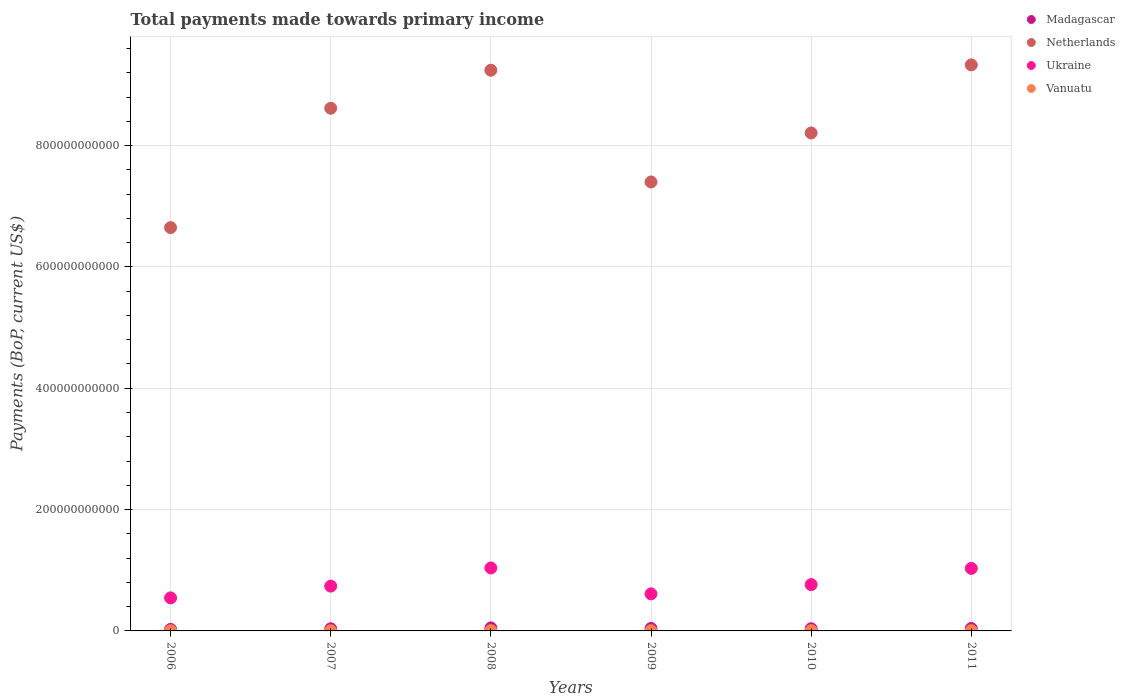Is the number of dotlines equal to the number of legend labels?
Your response must be concise. Yes. What is the total payments made towards primary income in Ukraine in 2009?
Your answer should be compact. 6.11e+1. Across all years, what is the maximum total payments made towards primary income in Ukraine?
Offer a very short reply. 1.04e+11. Across all years, what is the minimum total payments made towards primary income in Ukraine?
Provide a succinct answer. 5.45e+1. In which year was the total payments made towards primary income in Vanuatu maximum?
Keep it short and to the point. 2008. In which year was the total payments made towards primary income in Madagascar minimum?
Ensure brevity in your answer.  2006. What is the total total payments made towards primary income in Netherlands in the graph?
Offer a very short reply. 4.94e+12. What is the difference between the total payments made towards primary income in Netherlands in 2006 and that in 2009?
Ensure brevity in your answer.  -7.52e+1. What is the difference between the total payments made towards primary income in Netherlands in 2011 and the total payments made towards primary income in Ukraine in 2008?
Provide a succinct answer. 8.29e+11. What is the average total payments made towards primary income in Netherlands per year?
Your answer should be compact. 8.24e+11. In the year 2006, what is the difference between the total payments made towards primary income in Ukraine and total payments made towards primary income in Madagascar?
Keep it short and to the point. 5.20e+1. What is the ratio of the total payments made towards primary income in Ukraine in 2009 to that in 2010?
Ensure brevity in your answer.  0.8. Is the total payments made towards primary income in Vanuatu in 2006 less than that in 2007?
Ensure brevity in your answer.  Yes. What is the difference between the highest and the second highest total payments made towards primary income in Madagascar?
Offer a terse response. 8.70e+08. What is the difference between the highest and the lowest total payments made towards primary income in Madagascar?
Give a very brief answer. 2.44e+09. Is the sum of the total payments made towards primary income in Vanuatu in 2006 and 2009 greater than the maximum total payments made towards primary income in Ukraine across all years?
Provide a short and direct response. No. Is it the case that in every year, the sum of the total payments made towards primary income in Netherlands and total payments made towards primary income in Madagascar  is greater than the total payments made towards primary income in Vanuatu?
Your answer should be very brief. Yes. Does the total payments made towards primary income in Netherlands monotonically increase over the years?
Ensure brevity in your answer.  No. What is the difference between two consecutive major ticks on the Y-axis?
Offer a terse response. 2.00e+11. Are the values on the major ticks of Y-axis written in scientific E-notation?
Offer a very short reply. No. Does the graph contain grids?
Ensure brevity in your answer.  Yes. How many legend labels are there?
Provide a short and direct response. 4. What is the title of the graph?
Keep it short and to the point. Total payments made towards primary income. What is the label or title of the X-axis?
Ensure brevity in your answer.  Years. What is the label or title of the Y-axis?
Offer a very short reply. Payments (BoP, current US$). What is the Payments (BoP, current US$) in Madagascar in 2006?
Offer a terse response. 2.50e+09. What is the Payments (BoP, current US$) in Netherlands in 2006?
Keep it short and to the point. 6.65e+11. What is the Payments (BoP, current US$) in Ukraine in 2006?
Your response must be concise. 5.45e+1. What is the Payments (BoP, current US$) in Vanuatu in 2006?
Provide a short and direct response. 2.71e+08. What is the Payments (BoP, current US$) in Madagascar in 2007?
Provide a short and direct response. 3.55e+09. What is the Payments (BoP, current US$) in Netherlands in 2007?
Your response must be concise. 8.62e+11. What is the Payments (BoP, current US$) of Ukraine in 2007?
Offer a terse response. 7.39e+1. What is the Payments (BoP, current US$) in Vanuatu in 2007?
Offer a very short reply. 3.13e+08. What is the Payments (BoP, current US$) in Madagascar in 2008?
Make the answer very short. 4.94e+09. What is the Payments (BoP, current US$) in Netherlands in 2008?
Offer a very short reply. 9.24e+11. What is the Payments (BoP, current US$) of Ukraine in 2008?
Ensure brevity in your answer.  1.04e+11. What is the Payments (BoP, current US$) of Vanuatu in 2008?
Keep it short and to the point. 4.93e+08. What is the Payments (BoP, current US$) in Madagascar in 2009?
Provide a short and direct response. 4.07e+09. What is the Payments (BoP, current US$) of Netherlands in 2009?
Provide a short and direct response. 7.40e+11. What is the Payments (BoP, current US$) of Ukraine in 2009?
Your response must be concise. 6.11e+1. What is the Payments (BoP, current US$) of Vanuatu in 2009?
Offer a very short reply. 3.45e+08. What is the Payments (BoP, current US$) in Madagascar in 2010?
Make the answer very short. 3.62e+09. What is the Payments (BoP, current US$) of Netherlands in 2010?
Offer a very short reply. 8.21e+11. What is the Payments (BoP, current US$) of Ukraine in 2010?
Your answer should be very brief. 7.63e+1. What is the Payments (BoP, current US$) in Vanuatu in 2010?
Offer a terse response. 4.23e+08. What is the Payments (BoP, current US$) in Madagascar in 2011?
Keep it short and to the point. 4.02e+09. What is the Payments (BoP, current US$) of Netherlands in 2011?
Your answer should be compact. 9.33e+11. What is the Payments (BoP, current US$) in Ukraine in 2011?
Offer a terse response. 1.03e+11. What is the Payments (BoP, current US$) of Vanuatu in 2011?
Offer a very short reply. 4.66e+08. Across all years, what is the maximum Payments (BoP, current US$) in Madagascar?
Make the answer very short. 4.94e+09. Across all years, what is the maximum Payments (BoP, current US$) of Netherlands?
Your response must be concise. 9.33e+11. Across all years, what is the maximum Payments (BoP, current US$) in Ukraine?
Make the answer very short. 1.04e+11. Across all years, what is the maximum Payments (BoP, current US$) of Vanuatu?
Your answer should be very brief. 4.93e+08. Across all years, what is the minimum Payments (BoP, current US$) of Madagascar?
Your answer should be compact. 2.50e+09. Across all years, what is the minimum Payments (BoP, current US$) in Netherlands?
Offer a very short reply. 6.65e+11. Across all years, what is the minimum Payments (BoP, current US$) in Ukraine?
Offer a very short reply. 5.45e+1. Across all years, what is the minimum Payments (BoP, current US$) in Vanuatu?
Give a very brief answer. 2.71e+08. What is the total Payments (BoP, current US$) of Madagascar in the graph?
Your response must be concise. 2.27e+1. What is the total Payments (BoP, current US$) of Netherlands in the graph?
Offer a terse response. 4.94e+12. What is the total Payments (BoP, current US$) of Ukraine in the graph?
Make the answer very short. 4.73e+11. What is the total Payments (BoP, current US$) of Vanuatu in the graph?
Give a very brief answer. 2.31e+09. What is the difference between the Payments (BoP, current US$) of Madagascar in 2006 and that in 2007?
Your answer should be very brief. -1.05e+09. What is the difference between the Payments (BoP, current US$) of Netherlands in 2006 and that in 2007?
Offer a very short reply. -1.97e+11. What is the difference between the Payments (BoP, current US$) of Ukraine in 2006 and that in 2007?
Offer a terse response. -1.94e+1. What is the difference between the Payments (BoP, current US$) in Vanuatu in 2006 and that in 2007?
Keep it short and to the point. -4.24e+07. What is the difference between the Payments (BoP, current US$) of Madagascar in 2006 and that in 2008?
Offer a very short reply. -2.44e+09. What is the difference between the Payments (BoP, current US$) in Netherlands in 2006 and that in 2008?
Make the answer very short. -2.59e+11. What is the difference between the Payments (BoP, current US$) of Ukraine in 2006 and that in 2008?
Your answer should be very brief. -4.93e+1. What is the difference between the Payments (BoP, current US$) in Vanuatu in 2006 and that in 2008?
Provide a succinct answer. -2.22e+08. What is the difference between the Payments (BoP, current US$) of Madagascar in 2006 and that in 2009?
Your answer should be very brief. -1.57e+09. What is the difference between the Payments (BoP, current US$) in Netherlands in 2006 and that in 2009?
Give a very brief answer. -7.52e+1. What is the difference between the Payments (BoP, current US$) of Ukraine in 2006 and that in 2009?
Offer a very short reply. -6.62e+09. What is the difference between the Payments (BoP, current US$) of Vanuatu in 2006 and that in 2009?
Your answer should be very brief. -7.48e+07. What is the difference between the Payments (BoP, current US$) of Madagascar in 2006 and that in 2010?
Provide a succinct answer. -1.12e+09. What is the difference between the Payments (BoP, current US$) of Netherlands in 2006 and that in 2010?
Your response must be concise. -1.56e+11. What is the difference between the Payments (BoP, current US$) in Ukraine in 2006 and that in 2010?
Provide a short and direct response. -2.19e+1. What is the difference between the Payments (BoP, current US$) of Vanuatu in 2006 and that in 2010?
Your answer should be compact. -1.52e+08. What is the difference between the Payments (BoP, current US$) of Madagascar in 2006 and that in 2011?
Offer a terse response. -1.52e+09. What is the difference between the Payments (BoP, current US$) in Netherlands in 2006 and that in 2011?
Provide a short and direct response. -2.68e+11. What is the difference between the Payments (BoP, current US$) in Ukraine in 2006 and that in 2011?
Your answer should be very brief. -4.86e+1. What is the difference between the Payments (BoP, current US$) of Vanuatu in 2006 and that in 2011?
Provide a succinct answer. -1.95e+08. What is the difference between the Payments (BoP, current US$) in Madagascar in 2007 and that in 2008?
Keep it short and to the point. -1.39e+09. What is the difference between the Payments (BoP, current US$) of Netherlands in 2007 and that in 2008?
Ensure brevity in your answer.  -6.26e+1. What is the difference between the Payments (BoP, current US$) of Ukraine in 2007 and that in 2008?
Your answer should be very brief. -2.99e+1. What is the difference between the Payments (BoP, current US$) of Vanuatu in 2007 and that in 2008?
Give a very brief answer. -1.80e+08. What is the difference between the Payments (BoP, current US$) in Madagascar in 2007 and that in 2009?
Offer a very short reply. -5.16e+08. What is the difference between the Payments (BoP, current US$) in Netherlands in 2007 and that in 2009?
Your answer should be compact. 1.22e+11. What is the difference between the Payments (BoP, current US$) of Ukraine in 2007 and that in 2009?
Offer a terse response. 1.28e+1. What is the difference between the Payments (BoP, current US$) in Vanuatu in 2007 and that in 2009?
Offer a terse response. -3.23e+07. What is the difference between the Payments (BoP, current US$) in Madagascar in 2007 and that in 2010?
Offer a very short reply. -6.61e+07. What is the difference between the Payments (BoP, current US$) of Netherlands in 2007 and that in 2010?
Your answer should be very brief. 4.08e+1. What is the difference between the Payments (BoP, current US$) in Ukraine in 2007 and that in 2010?
Offer a very short reply. -2.47e+09. What is the difference between the Payments (BoP, current US$) in Vanuatu in 2007 and that in 2010?
Give a very brief answer. -1.10e+08. What is the difference between the Payments (BoP, current US$) in Madagascar in 2007 and that in 2011?
Provide a short and direct response. -4.66e+08. What is the difference between the Payments (BoP, current US$) in Netherlands in 2007 and that in 2011?
Provide a succinct answer. -7.15e+1. What is the difference between the Payments (BoP, current US$) of Ukraine in 2007 and that in 2011?
Offer a terse response. -2.92e+1. What is the difference between the Payments (BoP, current US$) of Vanuatu in 2007 and that in 2011?
Give a very brief answer. -1.53e+08. What is the difference between the Payments (BoP, current US$) of Madagascar in 2008 and that in 2009?
Keep it short and to the point. 8.70e+08. What is the difference between the Payments (BoP, current US$) in Netherlands in 2008 and that in 2009?
Make the answer very short. 1.84e+11. What is the difference between the Payments (BoP, current US$) of Ukraine in 2008 and that in 2009?
Offer a very short reply. 4.27e+1. What is the difference between the Payments (BoP, current US$) of Vanuatu in 2008 and that in 2009?
Give a very brief answer. 1.47e+08. What is the difference between the Payments (BoP, current US$) in Madagascar in 2008 and that in 2010?
Keep it short and to the point. 1.32e+09. What is the difference between the Payments (BoP, current US$) in Netherlands in 2008 and that in 2010?
Ensure brevity in your answer.  1.03e+11. What is the difference between the Payments (BoP, current US$) in Ukraine in 2008 and that in 2010?
Your answer should be compact. 2.75e+1. What is the difference between the Payments (BoP, current US$) in Vanuatu in 2008 and that in 2010?
Ensure brevity in your answer.  7.01e+07. What is the difference between the Payments (BoP, current US$) in Madagascar in 2008 and that in 2011?
Keep it short and to the point. 9.20e+08. What is the difference between the Payments (BoP, current US$) of Netherlands in 2008 and that in 2011?
Your response must be concise. -8.86e+09. What is the difference between the Payments (BoP, current US$) in Ukraine in 2008 and that in 2011?
Make the answer very short. 7.29e+08. What is the difference between the Payments (BoP, current US$) in Vanuatu in 2008 and that in 2011?
Keep it short and to the point. 2.70e+07. What is the difference between the Payments (BoP, current US$) in Madagascar in 2009 and that in 2010?
Make the answer very short. 4.50e+08. What is the difference between the Payments (BoP, current US$) of Netherlands in 2009 and that in 2010?
Your answer should be compact. -8.08e+1. What is the difference between the Payments (BoP, current US$) in Ukraine in 2009 and that in 2010?
Give a very brief answer. -1.52e+1. What is the difference between the Payments (BoP, current US$) of Vanuatu in 2009 and that in 2010?
Provide a succinct answer. -7.72e+07. What is the difference between the Payments (BoP, current US$) in Madagascar in 2009 and that in 2011?
Your answer should be very brief. 5.02e+07. What is the difference between the Payments (BoP, current US$) of Netherlands in 2009 and that in 2011?
Give a very brief answer. -1.93e+11. What is the difference between the Payments (BoP, current US$) of Ukraine in 2009 and that in 2011?
Offer a terse response. -4.20e+1. What is the difference between the Payments (BoP, current US$) in Vanuatu in 2009 and that in 2011?
Keep it short and to the point. -1.20e+08. What is the difference between the Payments (BoP, current US$) in Madagascar in 2010 and that in 2011?
Ensure brevity in your answer.  -4.00e+08. What is the difference between the Payments (BoP, current US$) in Netherlands in 2010 and that in 2011?
Provide a short and direct response. -1.12e+11. What is the difference between the Payments (BoP, current US$) in Ukraine in 2010 and that in 2011?
Keep it short and to the point. -2.67e+1. What is the difference between the Payments (BoP, current US$) of Vanuatu in 2010 and that in 2011?
Offer a terse response. -4.31e+07. What is the difference between the Payments (BoP, current US$) of Madagascar in 2006 and the Payments (BoP, current US$) of Netherlands in 2007?
Provide a succinct answer. -8.59e+11. What is the difference between the Payments (BoP, current US$) in Madagascar in 2006 and the Payments (BoP, current US$) in Ukraine in 2007?
Keep it short and to the point. -7.14e+1. What is the difference between the Payments (BoP, current US$) in Madagascar in 2006 and the Payments (BoP, current US$) in Vanuatu in 2007?
Make the answer very short. 2.19e+09. What is the difference between the Payments (BoP, current US$) in Netherlands in 2006 and the Payments (BoP, current US$) in Ukraine in 2007?
Ensure brevity in your answer.  5.91e+11. What is the difference between the Payments (BoP, current US$) of Netherlands in 2006 and the Payments (BoP, current US$) of Vanuatu in 2007?
Your response must be concise. 6.64e+11. What is the difference between the Payments (BoP, current US$) in Ukraine in 2006 and the Payments (BoP, current US$) in Vanuatu in 2007?
Give a very brief answer. 5.42e+1. What is the difference between the Payments (BoP, current US$) in Madagascar in 2006 and the Payments (BoP, current US$) in Netherlands in 2008?
Offer a very short reply. -9.22e+11. What is the difference between the Payments (BoP, current US$) of Madagascar in 2006 and the Payments (BoP, current US$) of Ukraine in 2008?
Keep it short and to the point. -1.01e+11. What is the difference between the Payments (BoP, current US$) in Madagascar in 2006 and the Payments (BoP, current US$) in Vanuatu in 2008?
Your response must be concise. 2.01e+09. What is the difference between the Payments (BoP, current US$) of Netherlands in 2006 and the Payments (BoP, current US$) of Ukraine in 2008?
Your answer should be compact. 5.61e+11. What is the difference between the Payments (BoP, current US$) of Netherlands in 2006 and the Payments (BoP, current US$) of Vanuatu in 2008?
Your answer should be very brief. 6.64e+11. What is the difference between the Payments (BoP, current US$) of Ukraine in 2006 and the Payments (BoP, current US$) of Vanuatu in 2008?
Offer a terse response. 5.40e+1. What is the difference between the Payments (BoP, current US$) of Madagascar in 2006 and the Payments (BoP, current US$) of Netherlands in 2009?
Provide a succinct answer. -7.38e+11. What is the difference between the Payments (BoP, current US$) in Madagascar in 2006 and the Payments (BoP, current US$) in Ukraine in 2009?
Your answer should be compact. -5.86e+1. What is the difference between the Payments (BoP, current US$) in Madagascar in 2006 and the Payments (BoP, current US$) in Vanuatu in 2009?
Give a very brief answer. 2.15e+09. What is the difference between the Payments (BoP, current US$) in Netherlands in 2006 and the Payments (BoP, current US$) in Ukraine in 2009?
Your answer should be very brief. 6.04e+11. What is the difference between the Payments (BoP, current US$) in Netherlands in 2006 and the Payments (BoP, current US$) in Vanuatu in 2009?
Your response must be concise. 6.64e+11. What is the difference between the Payments (BoP, current US$) of Ukraine in 2006 and the Payments (BoP, current US$) of Vanuatu in 2009?
Your answer should be very brief. 5.41e+1. What is the difference between the Payments (BoP, current US$) in Madagascar in 2006 and the Payments (BoP, current US$) in Netherlands in 2010?
Offer a terse response. -8.18e+11. What is the difference between the Payments (BoP, current US$) in Madagascar in 2006 and the Payments (BoP, current US$) in Ukraine in 2010?
Your answer should be compact. -7.38e+1. What is the difference between the Payments (BoP, current US$) in Madagascar in 2006 and the Payments (BoP, current US$) in Vanuatu in 2010?
Offer a terse response. 2.08e+09. What is the difference between the Payments (BoP, current US$) of Netherlands in 2006 and the Payments (BoP, current US$) of Ukraine in 2010?
Make the answer very short. 5.88e+11. What is the difference between the Payments (BoP, current US$) of Netherlands in 2006 and the Payments (BoP, current US$) of Vanuatu in 2010?
Provide a succinct answer. 6.64e+11. What is the difference between the Payments (BoP, current US$) of Ukraine in 2006 and the Payments (BoP, current US$) of Vanuatu in 2010?
Ensure brevity in your answer.  5.41e+1. What is the difference between the Payments (BoP, current US$) in Madagascar in 2006 and the Payments (BoP, current US$) in Netherlands in 2011?
Make the answer very short. -9.31e+11. What is the difference between the Payments (BoP, current US$) of Madagascar in 2006 and the Payments (BoP, current US$) of Ukraine in 2011?
Keep it short and to the point. -1.01e+11. What is the difference between the Payments (BoP, current US$) in Madagascar in 2006 and the Payments (BoP, current US$) in Vanuatu in 2011?
Provide a short and direct response. 2.03e+09. What is the difference between the Payments (BoP, current US$) of Netherlands in 2006 and the Payments (BoP, current US$) of Ukraine in 2011?
Ensure brevity in your answer.  5.62e+11. What is the difference between the Payments (BoP, current US$) in Netherlands in 2006 and the Payments (BoP, current US$) in Vanuatu in 2011?
Your answer should be compact. 6.64e+11. What is the difference between the Payments (BoP, current US$) in Ukraine in 2006 and the Payments (BoP, current US$) in Vanuatu in 2011?
Offer a terse response. 5.40e+1. What is the difference between the Payments (BoP, current US$) of Madagascar in 2007 and the Payments (BoP, current US$) of Netherlands in 2008?
Make the answer very short. -9.21e+11. What is the difference between the Payments (BoP, current US$) in Madagascar in 2007 and the Payments (BoP, current US$) in Ukraine in 2008?
Keep it short and to the point. -1.00e+11. What is the difference between the Payments (BoP, current US$) of Madagascar in 2007 and the Payments (BoP, current US$) of Vanuatu in 2008?
Your answer should be compact. 3.06e+09. What is the difference between the Payments (BoP, current US$) in Netherlands in 2007 and the Payments (BoP, current US$) in Ukraine in 2008?
Your response must be concise. 7.58e+11. What is the difference between the Payments (BoP, current US$) of Netherlands in 2007 and the Payments (BoP, current US$) of Vanuatu in 2008?
Provide a succinct answer. 8.61e+11. What is the difference between the Payments (BoP, current US$) of Ukraine in 2007 and the Payments (BoP, current US$) of Vanuatu in 2008?
Your answer should be very brief. 7.34e+1. What is the difference between the Payments (BoP, current US$) of Madagascar in 2007 and the Payments (BoP, current US$) of Netherlands in 2009?
Ensure brevity in your answer.  -7.36e+11. What is the difference between the Payments (BoP, current US$) in Madagascar in 2007 and the Payments (BoP, current US$) in Ukraine in 2009?
Offer a terse response. -5.76e+1. What is the difference between the Payments (BoP, current US$) in Madagascar in 2007 and the Payments (BoP, current US$) in Vanuatu in 2009?
Your response must be concise. 3.20e+09. What is the difference between the Payments (BoP, current US$) of Netherlands in 2007 and the Payments (BoP, current US$) of Ukraine in 2009?
Offer a terse response. 8.00e+11. What is the difference between the Payments (BoP, current US$) in Netherlands in 2007 and the Payments (BoP, current US$) in Vanuatu in 2009?
Keep it short and to the point. 8.61e+11. What is the difference between the Payments (BoP, current US$) in Ukraine in 2007 and the Payments (BoP, current US$) in Vanuatu in 2009?
Offer a very short reply. 7.35e+1. What is the difference between the Payments (BoP, current US$) of Madagascar in 2007 and the Payments (BoP, current US$) of Netherlands in 2010?
Offer a terse response. -8.17e+11. What is the difference between the Payments (BoP, current US$) in Madagascar in 2007 and the Payments (BoP, current US$) in Ukraine in 2010?
Provide a short and direct response. -7.28e+1. What is the difference between the Payments (BoP, current US$) in Madagascar in 2007 and the Payments (BoP, current US$) in Vanuatu in 2010?
Offer a very short reply. 3.13e+09. What is the difference between the Payments (BoP, current US$) of Netherlands in 2007 and the Payments (BoP, current US$) of Ukraine in 2010?
Keep it short and to the point. 7.85e+11. What is the difference between the Payments (BoP, current US$) in Netherlands in 2007 and the Payments (BoP, current US$) in Vanuatu in 2010?
Make the answer very short. 8.61e+11. What is the difference between the Payments (BoP, current US$) of Ukraine in 2007 and the Payments (BoP, current US$) of Vanuatu in 2010?
Offer a terse response. 7.34e+1. What is the difference between the Payments (BoP, current US$) in Madagascar in 2007 and the Payments (BoP, current US$) in Netherlands in 2011?
Your response must be concise. -9.30e+11. What is the difference between the Payments (BoP, current US$) in Madagascar in 2007 and the Payments (BoP, current US$) in Ukraine in 2011?
Offer a very short reply. -9.95e+1. What is the difference between the Payments (BoP, current US$) in Madagascar in 2007 and the Payments (BoP, current US$) in Vanuatu in 2011?
Keep it short and to the point. 3.08e+09. What is the difference between the Payments (BoP, current US$) in Netherlands in 2007 and the Payments (BoP, current US$) in Ukraine in 2011?
Make the answer very short. 7.58e+11. What is the difference between the Payments (BoP, current US$) of Netherlands in 2007 and the Payments (BoP, current US$) of Vanuatu in 2011?
Your answer should be compact. 8.61e+11. What is the difference between the Payments (BoP, current US$) of Ukraine in 2007 and the Payments (BoP, current US$) of Vanuatu in 2011?
Keep it short and to the point. 7.34e+1. What is the difference between the Payments (BoP, current US$) in Madagascar in 2008 and the Payments (BoP, current US$) in Netherlands in 2009?
Keep it short and to the point. -7.35e+11. What is the difference between the Payments (BoP, current US$) of Madagascar in 2008 and the Payments (BoP, current US$) of Ukraine in 2009?
Keep it short and to the point. -5.62e+1. What is the difference between the Payments (BoP, current US$) in Madagascar in 2008 and the Payments (BoP, current US$) in Vanuatu in 2009?
Your response must be concise. 4.59e+09. What is the difference between the Payments (BoP, current US$) of Netherlands in 2008 and the Payments (BoP, current US$) of Ukraine in 2009?
Give a very brief answer. 8.63e+11. What is the difference between the Payments (BoP, current US$) of Netherlands in 2008 and the Payments (BoP, current US$) of Vanuatu in 2009?
Provide a short and direct response. 9.24e+11. What is the difference between the Payments (BoP, current US$) of Ukraine in 2008 and the Payments (BoP, current US$) of Vanuatu in 2009?
Your answer should be very brief. 1.03e+11. What is the difference between the Payments (BoP, current US$) of Madagascar in 2008 and the Payments (BoP, current US$) of Netherlands in 2010?
Offer a very short reply. -8.16e+11. What is the difference between the Payments (BoP, current US$) of Madagascar in 2008 and the Payments (BoP, current US$) of Ukraine in 2010?
Provide a short and direct response. -7.14e+1. What is the difference between the Payments (BoP, current US$) of Madagascar in 2008 and the Payments (BoP, current US$) of Vanuatu in 2010?
Give a very brief answer. 4.51e+09. What is the difference between the Payments (BoP, current US$) of Netherlands in 2008 and the Payments (BoP, current US$) of Ukraine in 2010?
Offer a very short reply. 8.48e+11. What is the difference between the Payments (BoP, current US$) of Netherlands in 2008 and the Payments (BoP, current US$) of Vanuatu in 2010?
Provide a succinct answer. 9.24e+11. What is the difference between the Payments (BoP, current US$) in Ukraine in 2008 and the Payments (BoP, current US$) in Vanuatu in 2010?
Give a very brief answer. 1.03e+11. What is the difference between the Payments (BoP, current US$) of Madagascar in 2008 and the Payments (BoP, current US$) of Netherlands in 2011?
Ensure brevity in your answer.  -9.28e+11. What is the difference between the Payments (BoP, current US$) in Madagascar in 2008 and the Payments (BoP, current US$) in Ukraine in 2011?
Provide a succinct answer. -9.81e+1. What is the difference between the Payments (BoP, current US$) in Madagascar in 2008 and the Payments (BoP, current US$) in Vanuatu in 2011?
Your answer should be very brief. 4.47e+09. What is the difference between the Payments (BoP, current US$) of Netherlands in 2008 and the Payments (BoP, current US$) of Ukraine in 2011?
Provide a short and direct response. 8.21e+11. What is the difference between the Payments (BoP, current US$) in Netherlands in 2008 and the Payments (BoP, current US$) in Vanuatu in 2011?
Ensure brevity in your answer.  9.24e+11. What is the difference between the Payments (BoP, current US$) in Ukraine in 2008 and the Payments (BoP, current US$) in Vanuatu in 2011?
Provide a succinct answer. 1.03e+11. What is the difference between the Payments (BoP, current US$) of Madagascar in 2009 and the Payments (BoP, current US$) of Netherlands in 2010?
Your answer should be compact. -8.17e+11. What is the difference between the Payments (BoP, current US$) in Madagascar in 2009 and the Payments (BoP, current US$) in Ukraine in 2010?
Provide a succinct answer. -7.23e+1. What is the difference between the Payments (BoP, current US$) of Madagascar in 2009 and the Payments (BoP, current US$) of Vanuatu in 2010?
Provide a short and direct response. 3.64e+09. What is the difference between the Payments (BoP, current US$) in Netherlands in 2009 and the Payments (BoP, current US$) in Ukraine in 2010?
Keep it short and to the point. 6.64e+11. What is the difference between the Payments (BoP, current US$) in Netherlands in 2009 and the Payments (BoP, current US$) in Vanuatu in 2010?
Ensure brevity in your answer.  7.40e+11. What is the difference between the Payments (BoP, current US$) of Ukraine in 2009 and the Payments (BoP, current US$) of Vanuatu in 2010?
Provide a succinct answer. 6.07e+1. What is the difference between the Payments (BoP, current US$) in Madagascar in 2009 and the Payments (BoP, current US$) in Netherlands in 2011?
Make the answer very short. -9.29e+11. What is the difference between the Payments (BoP, current US$) in Madagascar in 2009 and the Payments (BoP, current US$) in Ukraine in 2011?
Make the answer very short. -9.90e+1. What is the difference between the Payments (BoP, current US$) of Madagascar in 2009 and the Payments (BoP, current US$) of Vanuatu in 2011?
Your response must be concise. 3.60e+09. What is the difference between the Payments (BoP, current US$) in Netherlands in 2009 and the Payments (BoP, current US$) in Ukraine in 2011?
Provide a succinct answer. 6.37e+11. What is the difference between the Payments (BoP, current US$) in Netherlands in 2009 and the Payments (BoP, current US$) in Vanuatu in 2011?
Your answer should be very brief. 7.40e+11. What is the difference between the Payments (BoP, current US$) in Ukraine in 2009 and the Payments (BoP, current US$) in Vanuatu in 2011?
Make the answer very short. 6.06e+1. What is the difference between the Payments (BoP, current US$) of Madagascar in 2010 and the Payments (BoP, current US$) of Netherlands in 2011?
Ensure brevity in your answer.  -9.29e+11. What is the difference between the Payments (BoP, current US$) in Madagascar in 2010 and the Payments (BoP, current US$) in Ukraine in 2011?
Offer a terse response. -9.95e+1. What is the difference between the Payments (BoP, current US$) of Madagascar in 2010 and the Payments (BoP, current US$) of Vanuatu in 2011?
Provide a succinct answer. 3.15e+09. What is the difference between the Payments (BoP, current US$) in Netherlands in 2010 and the Payments (BoP, current US$) in Ukraine in 2011?
Provide a short and direct response. 7.18e+11. What is the difference between the Payments (BoP, current US$) of Netherlands in 2010 and the Payments (BoP, current US$) of Vanuatu in 2011?
Ensure brevity in your answer.  8.20e+11. What is the difference between the Payments (BoP, current US$) in Ukraine in 2010 and the Payments (BoP, current US$) in Vanuatu in 2011?
Your answer should be very brief. 7.59e+1. What is the average Payments (BoP, current US$) in Madagascar per year?
Provide a short and direct response. 3.78e+09. What is the average Payments (BoP, current US$) of Netherlands per year?
Give a very brief answer. 8.24e+11. What is the average Payments (BoP, current US$) in Ukraine per year?
Your response must be concise. 7.88e+1. What is the average Payments (BoP, current US$) in Vanuatu per year?
Ensure brevity in your answer.  3.85e+08. In the year 2006, what is the difference between the Payments (BoP, current US$) of Madagascar and Payments (BoP, current US$) of Netherlands?
Provide a short and direct response. -6.62e+11. In the year 2006, what is the difference between the Payments (BoP, current US$) of Madagascar and Payments (BoP, current US$) of Ukraine?
Provide a short and direct response. -5.20e+1. In the year 2006, what is the difference between the Payments (BoP, current US$) of Madagascar and Payments (BoP, current US$) of Vanuatu?
Your answer should be compact. 2.23e+09. In the year 2006, what is the difference between the Payments (BoP, current US$) of Netherlands and Payments (BoP, current US$) of Ukraine?
Keep it short and to the point. 6.10e+11. In the year 2006, what is the difference between the Payments (BoP, current US$) of Netherlands and Payments (BoP, current US$) of Vanuatu?
Ensure brevity in your answer.  6.65e+11. In the year 2006, what is the difference between the Payments (BoP, current US$) of Ukraine and Payments (BoP, current US$) of Vanuatu?
Provide a succinct answer. 5.42e+1. In the year 2007, what is the difference between the Payments (BoP, current US$) of Madagascar and Payments (BoP, current US$) of Netherlands?
Keep it short and to the point. -8.58e+11. In the year 2007, what is the difference between the Payments (BoP, current US$) of Madagascar and Payments (BoP, current US$) of Ukraine?
Give a very brief answer. -7.03e+1. In the year 2007, what is the difference between the Payments (BoP, current US$) in Madagascar and Payments (BoP, current US$) in Vanuatu?
Keep it short and to the point. 3.24e+09. In the year 2007, what is the difference between the Payments (BoP, current US$) in Netherlands and Payments (BoP, current US$) in Ukraine?
Offer a terse response. 7.88e+11. In the year 2007, what is the difference between the Payments (BoP, current US$) in Netherlands and Payments (BoP, current US$) in Vanuatu?
Give a very brief answer. 8.61e+11. In the year 2007, what is the difference between the Payments (BoP, current US$) in Ukraine and Payments (BoP, current US$) in Vanuatu?
Your answer should be very brief. 7.35e+1. In the year 2008, what is the difference between the Payments (BoP, current US$) in Madagascar and Payments (BoP, current US$) in Netherlands?
Keep it short and to the point. -9.19e+11. In the year 2008, what is the difference between the Payments (BoP, current US$) in Madagascar and Payments (BoP, current US$) in Ukraine?
Make the answer very short. -9.89e+1. In the year 2008, what is the difference between the Payments (BoP, current US$) of Madagascar and Payments (BoP, current US$) of Vanuatu?
Ensure brevity in your answer.  4.44e+09. In the year 2008, what is the difference between the Payments (BoP, current US$) of Netherlands and Payments (BoP, current US$) of Ukraine?
Give a very brief answer. 8.20e+11. In the year 2008, what is the difference between the Payments (BoP, current US$) of Netherlands and Payments (BoP, current US$) of Vanuatu?
Keep it short and to the point. 9.24e+11. In the year 2008, what is the difference between the Payments (BoP, current US$) of Ukraine and Payments (BoP, current US$) of Vanuatu?
Make the answer very short. 1.03e+11. In the year 2009, what is the difference between the Payments (BoP, current US$) in Madagascar and Payments (BoP, current US$) in Netherlands?
Your answer should be compact. -7.36e+11. In the year 2009, what is the difference between the Payments (BoP, current US$) of Madagascar and Payments (BoP, current US$) of Ukraine?
Make the answer very short. -5.70e+1. In the year 2009, what is the difference between the Payments (BoP, current US$) of Madagascar and Payments (BoP, current US$) of Vanuatu?
Keep it short and to the point. 3.72e+09. In the year 2009, what is the difference between the Payments (BoP, current US$) in Netherlands and Payments (BoP, current US$) in Ukraine?
Your answer should be very brief. 6.79e+11. In the year 2009, what is the difference between the Payments (BoP, current US$) in Netherlands and Payments (BoP, current US$) in Vanuatu?
Your answer should be compact. 7.40e+11. In the year 2009, what is the difference between the Payments (BoP, current US$) in Ukraine and Payments (BoP, current US$) in Vanuatu?
Give a very brief answer. 6.08e+1. In the year 2010, what is the difference between the Payments (BoP, current US$) of Madagascar and Payments (BoP, current US$) of Netherlands?
Ensure brevity in your answer.  -8.17e+11. In the year 2010, what is the difference between the Payments (BoP, current US$) in Madagascar and Payments (BoP, current US$) in Ukraine?
Keep it short and to the point. -7.27e+1. In the year 2010, what is the difference between the Payments (BoP, current US$) in Madagascar and Payments (BoP, current US$) in Vanuatu?
Your answer should be compact. 3.19e+09. In the year 2010, what is the difference between the Payments (BoP, current US$) of Netherlands and Payments (BoP, current US$) of Ukraine?
Provide a short and direct response. 7.44e+11. In the year 2010, what is the difference between the Payments (BoP, current US$) in Netherlands and Payments (BoP, current US$) in Vanuatu?
Ensure brevity in your answer.  8.20e+11. In the year 2010, what is the difference between the Payments (BoP, current US$) of Ukraine and Payments (BoP, current US$) of Vanuatu?
Ensure brevity in your answer.  7.59e+1. In the year 2011, what is the difference between the Payments (BoP, current US$) in Madagascar and Payments (BoP, current US$) in Netherlands?
Your answer should be compact. -9.29e+11. In the year 2011, what is the difference between the Payments (BoP, current US$) of Madagascar and Payments (BoP, current US$) of Ukraine?
Provide a succinct answer. -9.91e+1. In the year 2011, what is the difference between the Payments (BoP, current US$) of Madagascar and Payments (BoP, current US$) of Vanuatu?
Your answer should be compact. 3.55e+09. In the year 2011, what is the difference between the Payments (BoP, current US$) in Netherlands and Payments (BoP, current US$) in Ukraine?
Your response must be concise. 8.30e+11. In the year 2011, what is the difference between the Payments (BoP, current US$) of Netherlands and Payments (BoP, current US$) of Vanuatu?
Ensure brevity in your answer.  9.33e+11. In the year 2011, what is the difference between the Payments (BoP, current US$) in Ukraine and Payments (BoP, current US$) in Vanuatu?
Offer a very short reply. 1.03e+11. What is the ratio of the Payments (BoP, current US$) in Madagascar in 2006 to that in 2007?
Keep it short and to the point. 0.7. What is the ratio of the Payments (BoP, current US$) of Netherlands in 2006 to that in 2007?
Offer a terse response. 0.77. What is the ratio of the Payments (BoP, current US$) of Ukraine in 2006 to that in 2007?
Your response must be concise. 0.74. What is the ratio of the Payments (BoP, current US$) in Vanuatu in 2006 to that in 2007?
Offer a terse response. 0.86. What is the ratio of the Payments (BoP, current US$) of Madagascar in 2006 to that in 2008?
Your answer should be very brief. 0.51. What is the ratio of the Payments (BoP, current US$) of Netherlands in 2006 to that in 2008?
Your answer should be compact. 0.72. What is the ratio of the Payments (BoP, current US$) of Ukraine in 2006 to that in 2008?
Your answer should be very brief. 0.52. What is the ratio of the Payments (BoP, current US$) of Vanuatu in 2006 to that in 2008?
Keep it short and to the point. 0.55. What is the ratio of the Payments (BoP, current US$) in Madagascar in 2006 to that in 2009?
Your answer should be compact. 0.61. What is the ratio of the Payments (BoP, current US$) of Netherlands in 2006 to that in 2009?
Provide a short and direct response. 0.9. What is the ratio of the Payments (BoP, current US$) of Ukraine in 2006 to that in 2009?
Your answer should be very brief. 0.89. What is the ratio of the Payments (BoP, current US$) in Vanuatu in 2006 to that in 2009?
Ensure brevity in your answer.  0.78. What is the ratio of the Payments (BoP, current US$) in Madagascar in 2006 to that in 2010?
Your response must be concise. 0.69. What is the ratio of the Payments (BoP, current US$) of Netherlands in 2006 to that in 2010?
Offer a very short reply. 0.81. What is the ratio of the Payments (BoP, current US$) of Ukraine in 2006 to that in 2010?
Keep it short and to the point. 0.71. What is the ratio of the Payments (BoP, current US$) of Vanuatu in 2006 to that in 2010?
Keep it short and to the point. 0.64. What is the ratio of the Payments (BoP, current US$) of Madagascar in 2006 to that in 2011?
Offer a very short reply. 0.62. What is the ratio of the Payments (BoP, current US$) in Netherlands in 2006 to that in 2011?
Offer a very short reply. 0.71. What is the ratio of the Payments (BoP, current US$) of Ukraine in 2006 to that in 2011?
Your answer should be compact. 0.53. What is the ratio of the Payments (BoP, current US$) in Vanuatu in 2006 to that in 2011?
Offer a very short reply. 0.58. What is the ratio of the Payments (BoP, current US$) of Madagascar in 2007 to that in 2008?
Keep it short and to the point. 0.72. What is the ratio of the Payments (BoP, current US$) in Netherlands in 2007 to that in 2008?
Your response must be concise. 0.93. What is the ratio of the Payments (BoP, current US$) in Ukraine in 2007 to that in 2008?
Offer a terse response. 0.71. What is the ratio of the Payments (BoP, current US$) in Vanuatu in 2007 to that in 2008?
Provide a short and direct response. 0.64. What is the ratio of the Payments (BoP, current US$) in Madagascar in 2007 to that in 2009?
Provide a short and direct response. 0.87. What is the ratio of the Payments (BoP, current US$) in Netherlands in 2007 to that in 2009?
Provide a short and direct response. 1.16. What is the ratio of the Payments (BoP, current US$) in Ukraine in 2007 to that in 2009?
Offer a terse response. 1.21. What is the ratio of the Payments (BoP, current US$) in Vanuatu in 2007 to that in 2009?
Your answer should be compact. 0.91. What is the ratio of the Payments (BoP, current US$) in Madagascar in 2007 to that in 2010?
Offer a very short reply. 0.98. What is the ratio of the Payments (BoP, current US$) in Netherlands in 2007 to that in 2010?
Provide a succinct answer. 1.05. What is the ratio of the Payments (BoP, current US$) in Ukraine in 2007 to that in 2010?
Make the answer very short. 0.97. What is the ratio of the Payments (BoP, current US$) of Vanuatu in 2007 to that in 2010?
Ensure brevity in your answer.  0.74. What is the ratio of the Payments (BoP, current US$) of Madagascar in 2007 to that in 2011?
Ensure brevity in your answer.  0.88. What is the ratio of the Payments (BoP, current US$) of Netherlands in 2007 to that in 2011?
Your answer should be very brief. 0.92. What is the ratio of the Payments (BoP, current US$) in Ukraine in 2007 to that in 2011?
Offer a terse response. 0.72. What is the ratio of the Payments (BoP, current US$) of Vanuatu in 2007 to that in 2011?
Offer a terse response. 0.67. What is the ratio of the Payments (BoP, current US$) in Madagascar in 2008 to that in 2009?
Give a very brief answer. 1.21. What is the ratio of the Payments (BoP, current US$) in Netherlands in 2008 to that in 2009?
Ensure brevity in your answer.  1.25. What is the ratio of the Payments (BoP, current US$) of Ukraine in 2008 to that in 2009?
Provide a short and direct response. 1.7. What is the ratio of the Payments (BoP, current US$) in Vanuatu in 2008 to that in 2009?
Your response must be concise. 1.43. What is the ratio of the Payments (BoP, current US$) in Madagascar in 2008 to that in 2010?
Your answer should be compact. 1.37. What is the ratio of the Payments (BoP, current US$) in Netherlands in 2008 to that in 2010?
Keep it short and to the point. 1.13. What is the ratio of the Payments (BoP, current US$) of Ukraine in 2008 to that in 2010?
Ensure brevity in your answer.  1.36. What is the ratio of the Payments (BoP, current US$) in Vanuatu in 2008 to that in 2010?
Your answer should be very brief. 1.17. What is the ratio of the Payments (BoP, current US$) of Madagascar in 2008 to that in 2011?
Your response must be concise. 1.23. What is the ratio of the Payments (BoP, current US$) of Netherlands in 2008 to that in 2011?
Provide a succinct answer. 0.99. What is the ratio of the Payments (BoP, current US$) of Ukraine in 2008 to that in 2011?
Provide a succinct answer. 1.01. What is the ratio of the Payments (BoP, current US$) of Vanuatu in 2008 to that in 2011?
Your answer should be compact. 1.06. What is the ratio of the Payments (BoP, current US$) of Madagascar in 2009 to that in 2010?
Keep it short and to the point. 1.12. What is the ratio of the Payments (BoP, current US$) of Netherlands in 2009 to that in 2010?
Provide a short and direct response. 0.9. What is the ratio of the Payments (BoP, current US$) in Ukraine in 2009 to that in 2010?
Offer a very short reply. 0.8. What is the ratio of the Payments (BoP, current US$) of Vanuatu in 2009 to that in 2010?
Your answer should be very brief. 0.82. What is the ratio of the Payments (BoP, current US$) of Madagascar in 2009 to that in 2011?
Keep it short and to the point. 1.01. What is the ratio of the Payments (BoP, current US$) of Netherlands in 2009 to that in 2011?
Ensure brevity in your answer.  0.79. What is the ratio of the Payments (BoP, current US$) in Ukraine in 2009 to that in 2011?
Your answer should be compact. 0.59. What is the ratio of the Payments (BoP, current US$) of Vanuatu in 2009 to that in 2011?
Your answer should be very brief. 0.74. What is the ratio of the Payments (BoP, current US$) in Madagascar in 2010 to that in 2011?
Offer a very short reply. 0.9. What is the ratio of the Payments (BoP, current US$) of Netherlands in 2010 to that in 2011?
Your answer should be compact. 0.88. What is the ratio of the Payments (BoP, current US$) in Ukraine in 2010 to that in 2011?
Offer a terse response. 0.74. What is the ratio of the Payments (BoP, current US$) of Vanuatu in 2010 to that in 2011?
Your answer should be compact. 0.91. What is the difference between the highest and the second highest Payments (BoP, current US$) of Madagascar?
Provide a short and direct response. 8.70e+08. What is the difference between the highest and the second highest Payments (BoP, current US$) in Netherlands?
Ensure brevity in your answer.  8.86e+09. What is the difference between the highest and the second highest Payments (BoP, current US$) in Ukraine?
Your answer should be very brief. 7.29e+08. What is the difference between the highest and the second highest Payments (BoP, current US$) in Vanuatu?
Offer a terse response. 2.70e+07. What is the difference between the highest and the lowest Payments (BoP, current US$) in Madagascar?
Keep it short and to the point. 2.44e+09. What is the difference between the highest and the lowest Payments (BoP, current US$) in Netherlands?
Your answer should be compact. 2.68e+11. What is the difference between the highest and the lowest Payments (BoP, current US$) of Ukraine?
Your answer should be very brief. 4.93e+1. What is the difference between the highest and the lowest Payments (BoP, current US$) in Vanuatu?
Your answer should be very brief. 2.22e+08. 